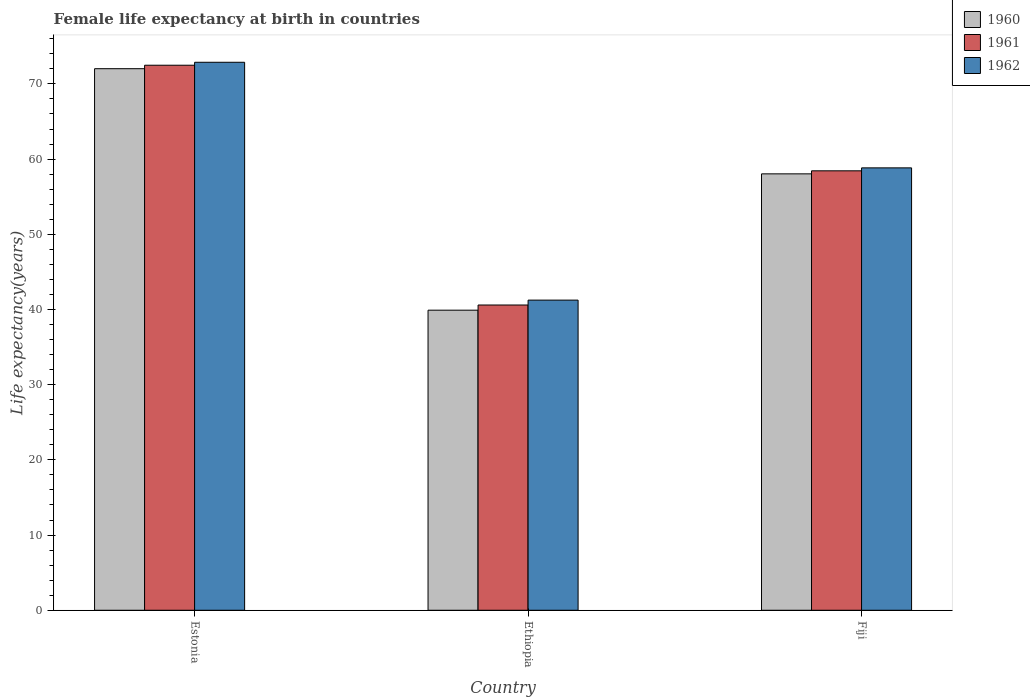How many different coloured bars are there?
Provide a succinct answer. 3. How many bars are there on the 3rd tick from the left?
Your response must be concise. 3. How many bars are there on the 2nd tick from the right?
Give a very brief answer. 3. What is the label of the 3rd group of bars from the left?
Keep it short and to the point. Fiji. In how many cases, is the number of bars for a given country not equal to the number of legend labels?
Ensure brevity in your answer.  0. What is the female life expectancy at birth in 1961 in Fiji?
Ensure brevity in your answer.  58.44. Across all countries, what is the maximum female life expectancy at birth in 1962?
Your response must be concise. 72.88. Across all countries, what is the minimum female life expectancy at birth in 1961?
Your answer should be compact. 40.6. In which country was the female life expectancy at birth in 1961 maximum?
Make the answer very short. Estonia. In which country was the female life expectancy at birth in 1961 minimum?
Make the answer very short. Ethiopia. What is the total female life expectancy at birth in 1962 in the graph?
Provide a short and direct response. 172.96. What is the difference between the female life expectancy at birth in 1962 in Estonia and that in Fiji?
Your answer should be compact. 14.04. What is the difference between the female life expectancy at birth in 1962 in Estonia and the female life expectancy at birth in 1960 in Ethiopia?
Provide a succinct answer. 32.97. What is the average female life expectancy at birth in 1961 per country?
Provide a succinct answer. 57.17. What is the difference between the female life expectancy at birth of/in 1960 and female life expectancy at birth of/in 1962 in Ethiopia?
Provide a short and direct response. -1.34. What is the ratio of the female life expectancy at birth in 1960 in Ethiopia to that in Fiji?
Your response must be concise. 0.69. Is the female life expectancy at birth in 1961 in Estonia less than that in Fiji?
Offer a terse response. No. What is the difference between the highest and the second highest female life expectancy at birth in 1960?
Provide a short and direct response. 13.98. What is the difference between the highest and the lowest female life expectancy at birth in 1962?
Ensure brevity in your answer.  31.63. In how many countries, is the female life expectancy at birth in 1960 greater than the average female life expectancy at birth in 1960 taken over all countries?
Give a very brief answer. 2. What does the 2nd bar from the right in Estonia represents?
Provide a succinct answer. 1961. How many bars are there?
Make the answer very short. 9. What is the difference between two consecutive major ticks on the Y-axis?
Offer a terse response. 10. Are the values on the major ticks of Y-axis written in scientific E-notation?
Your response must be concise. No. Does the graph contain any zero values?
Provide a succinct answer. No. Does the graph contain grids?
Provide a succinct answer. No. Where does the legend appear in the graph?
Give a very brief answer. Top right. What is the title of the graph?
Your answer should be very brief. Female life expectancy at birth in countries. Does "1967" appear as one of the legend labels in the graph?
Your response must be concise. No. What is the label or title of the Y-axis?
Keep it short and to the point. Life expectancy(years). What is the Life expectancy(years) in 1960 in Estonia?
Provide a short and direct response. 72.02. What is the Life expectancy(years) in 1961 in Estonia?
Make the answer very short. 72.48. What is the Life expectancy(years) in 1962 in Estonia?
Offer a terse response. 72.88. What is the Life expectancy(years) in 1960 in Ethiopia?
Provide a short and direct response. 39.91. What is the Life expectancy(years) of 1961 in Ethiopia?
Make the answer very short. 40.6. What is the Life expectancy(years) of 1962 in Ethiopia?
Give a very brief answer. 41.25. What is the Life expectancy(years) in 1960 in Fiji?
Keep it short and to the point. 58.04. What is the Life expectancy(years) of 1961 in Fiji?
Your answer should be very brief. 58.44. What is the Life expectancy(years) in 1962 in Fiji?
Your answer should be compact. 58.84. Across all countries, what is the maximum Life expectancy(years) of 1960?
Keep it short and to the point. 72.02. Across all countries, what is the maximum Life expectancy(years) of 1961?
Ensure brevity in your answer.  72.48. Across all countries, what is the maximum Life expectancy(years) of 1962?
Offer a very short reply. 72.88. Across all countries, what is the minimum Life expectancy(years) in 1960?
Make the answer very short. 39.91. Across all countries, what is the minimum Life expectancy(years) of 1961?
Provide a succinct answer. 40.6. Across all countries, what is the minimum Life expectancy(years) in 1962?
Provide a short and direct response. 41.25. What is the total Life expectancy(years) of 1960 in the graph?
Offer a terse response. 169.97. What is the total Life expectancy(years) in 1961 in the graph?
Your answer should be very brief. 171.52. What is the total Life expectancy(years) in 1962 in the graph?
Offer a very short reply. 172.96. What is the difference between the Life expectancy(years) in 1960 in Estonia and that in Ethiopia?
Your answer should be very brief. 32.11. What is the difference between the Life expectancy(years) of 1961 in Estonia and that in Ethiopia?
Your response must be concise. 31.89. What is the difference between the Life expectancy(years) of 1962 in Estonia and that in Ethiopia?
Your answer should be compact. 31.63. What is the difference between the Life expectancy(years) of 1960 in Estonia and that in Fiji?
Provide a short and direct response. 13.98. What is the difference between the Life expectancy(years) in 1961 in Estonia and that in Fiji?
Provide a short and direct response. 14.04. What is the difference between the Life expectancy(years) of 1962 in Estonia and that in Fiji?
Your answer should be compact. 14.04. What is the difference between the Life expectancy(years) of 1960 in Ethiopia and that in Fiji?
Your answer should be very brief. -18.13. What is the difference between the Life expectancy(years) in 1961 in Ethiopia and that in Fiji?
Offer a very short reply. -17.84. What is the difference between the Life expectancy(years) of 1962 in Ethiopia and that in Fiji?
Give a very brief answer. -17.59. What is the difference between the Life expectancy(years) of 1960 in Estonia and the Life expectancy(years) of 1961 in Ethiopia?
Your answer should be compact. 31.43. What is the difference between the Life expectancy(years) in 1960 in Estonia and the Life expectancy(years) in 1962 in Ethiopia?
Ensure brevity in your answer.  30.78. What is the difference between the Life expectancy(years) in 1961 in Estonia and the Life expectancy(years) in 1962 in Ethiopia?
Ensure brevity in your answer.  31.24. What is the difference between the Life expectancy(years) of 1960 in Estonia and the Life expectancy(years) of 1961 in Fiji?
Keep it short and to the point. 13.58. What is the difference between the Life expectancy(years) in 1960 in Estonia and the Life expectancy(years) in 1962 in Fiji?
Make the answer very short. 13.19. What is the difference between the Life expectancy(years) in 1961 in Estonia and the Life expectancy(years) in 1962 in Fiji?
Provide a succinct answer. 13.65. What is the difference between the Life expectancy(years) in 1960 in Ethiopia and the Life expectancy(years) in 1961 in Fiji?
Give a very brief answer. -18.53. What is the difference between the Life expectancy(years) in 1960 in Ethiopia and the Life expectancy(years) in 1962 in Fiji?
Make the answer very short. -18.93. What is the difference between the Life expectancy(years) in 1961 in Ethiopia and the Life expectancy(years) in 1962 in Fiji?
Provide a short and direct response. -18.24. What is the average Life expectancy(years) in 1960 per country?
Ensure brevity in your answer.  56.66. What is the average Life expectancy(years) in 1961 per country?
Ensure brevity in your answer.  57.17. What is the average Life expectancy(years) of 1962 per country?
Make the answer very short. 57.65. What is the difference between the Life expectancy(years) of 1960 and Life expectancy(years) of 1961 in Estonia?
Provide a succinct answer. -0.46. What is the difference between the Life expectancy(years) of 1960 and Life expectancy(years) of 1962 in Estonia?
Offer a terse response. -0.85. What is the difference between the Life expectancy(years) in 1961 and Life expectancy(years) in 1962 in Estonia?
Ensure brevity in your answer.  -0.39. What is the difference between the Life expectancy(years) in 1960 and Life expectancy(years) in 1961 in Ethiopia?
Your response must be concise. -0.69. What is the difference between the Life expectancy(years) in 1960 and Life expectancy(years) in 1962 in Ethiopia?
Provide a succinct answer. -1.34. What is the difference between the Life expectancy(years) of 1961 and Life expectancy(years) of 1962 in Ethiopia?
Your answer should be very brief. -0.65. What is the difference between the Life expectancy(years) of 1960 and Life expectancy(years) of 1961 in Fiji?
Keep it short and to the point. -0.4. What is the difference between the Life expectancy(years) in 1960 and Life expectancy(years) in 1962 in Fiji?
Offer a very short reply. -0.8. What is the difference between the Life expectancy(years) in 1961 and Life expectancy(years) in 1962 in Fiji?
Keep it short and to the point. -0.39. What is the ratio of the Life expectancy(years) in 1960 in Estonia to that in Ethiopia?
Ensure brevity in your answer.  1.8. What is the ratio of the Life expectancy(years) in 1961 in Estonia to that in Ethiopia?
Provide a short and direct response. 1.79. What is the ratio of the Life expectancy(years) of 1962 in Estonia to that in Ethiopia?
Provide a short and direct response. 1.77. What is the ratio of the Life expectancy(years) of 1960 in Estonia to that in Fiji?
Ensure brevity in your answer.  1.24. What is the ratio of the Life expectancy(years) in 1961 in Estonia to that in Fiji?
Offer a very short reply. 1.24. What is the ratio of the Life expectancy(years) in 1962 in Estonia to that in Fiji?
Give a very brief answer. 1.24. What is the ratio of the Life expectancy(years) in 1960 in Ethiopia to that in Fiji?
Offer a very short reply. 0.69. What is the ratio of the Life expectancy(years) in 1961 in Ethiopia to that in Fiji?
Your answer should be very brief. 0.69. What is the ratio of the Life expectancy(years) in 1962 in Ethiopia to that in Fiji?
Your response must be concise. 0.7. What is the difference between the highest and the second highest Life expectancy(years) of 1960?
Offer a very short reply. 13.98. What is the difference between the highest and the second highest Life expectancy(years) in 1961?
Offer a terse response. 14.04. What is the difference between the highest and the second highest Life expectancy(years) of 1962?
Offer a very short reply. 14.04. What is the difference between the highest and the lowest Life expectancy(years) in 1960?
Provide a short and direct response. 32.11. What is the difference between the highest and the lowest Life expectancy(years) of 1961?
Offer a very short reply. 31.89. What is the difference between the highest and the lowest Life expectancy(years) of 1962?
Offer a very short reply. 31.63. 